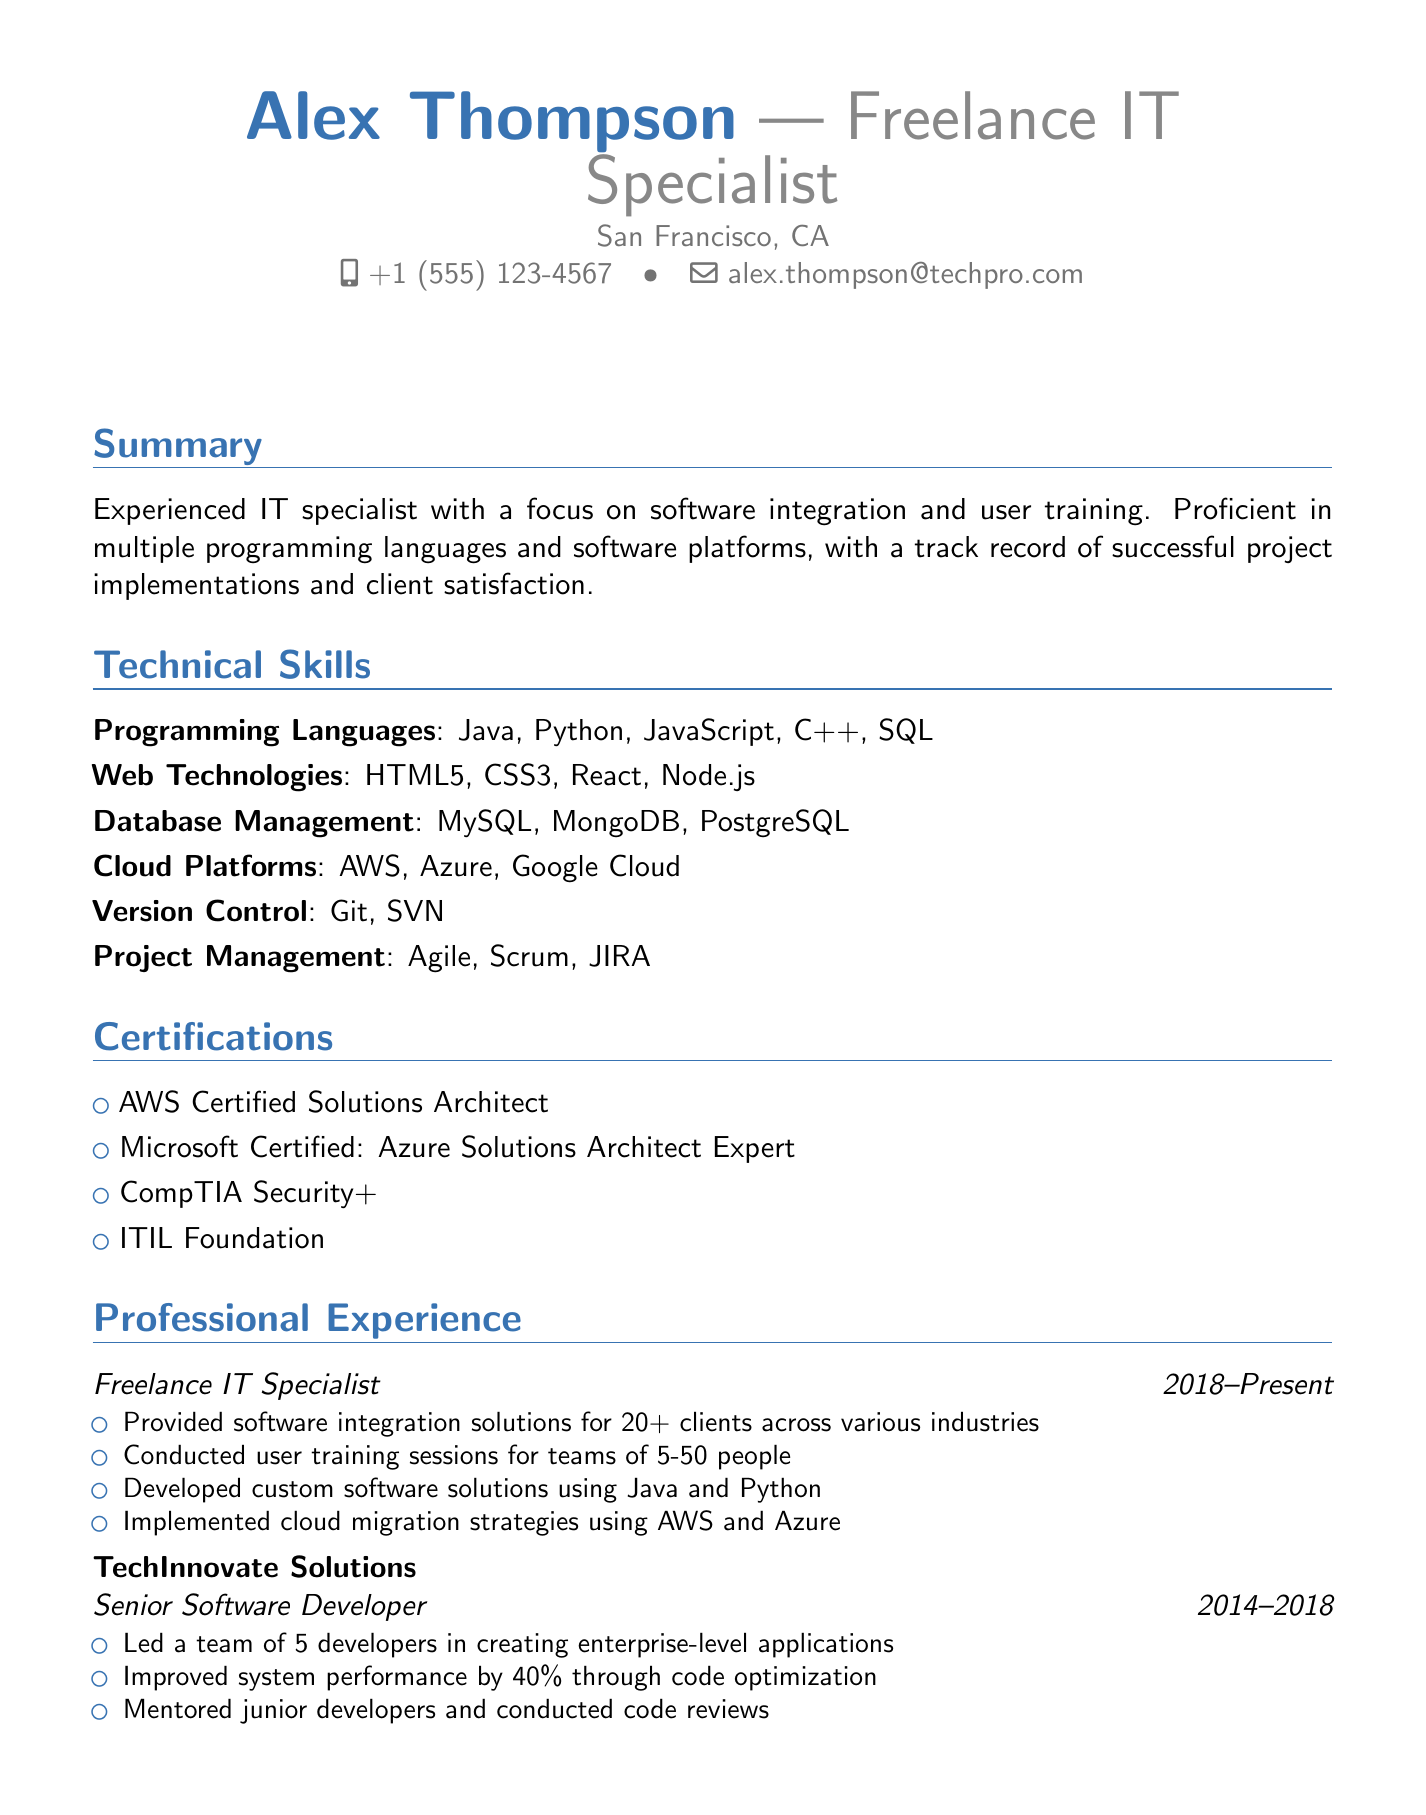What is the name of the IT specialist? The document states the name as Alex Thompson.
Answer: Alex Thompson What year did the individual graduate? The education section indicates the graduation year is 2014.
Answer: 2014 How many clients has the IT specialist provided solutions for? It's mentioned that software integration solutions were provided for 20+ clients.
Answer: 20+ What programming language is listed first in the skills? The technical skills section lists Java as the first programming language.
Answer: Java Which cloud platforms are mentioned? The document includes AWS, Azure, and Google Cloud as cloud platforms.
Answer: AWS, Azure, Google Cloud What position did Alex hold prior to becoming a freelance IT specialist? The professional experience section lists Senior Software Developer as the prior position.
Answer: Senior Software Developer How many developers did Alex lead in their previous role? The highlights note leading a team of 5 developers.
Answer: 5 What certification related to cloud architecture does Alex have? The certifications section mentions the AWS Certified Solutions Architect as a relevant qualification.
Answer: AWS Certified Solutions Architect What type of training sessions did Alex conduct? The document specifies conducting user training sessions for teams of 5-50 people.
Answer: User training sessions 